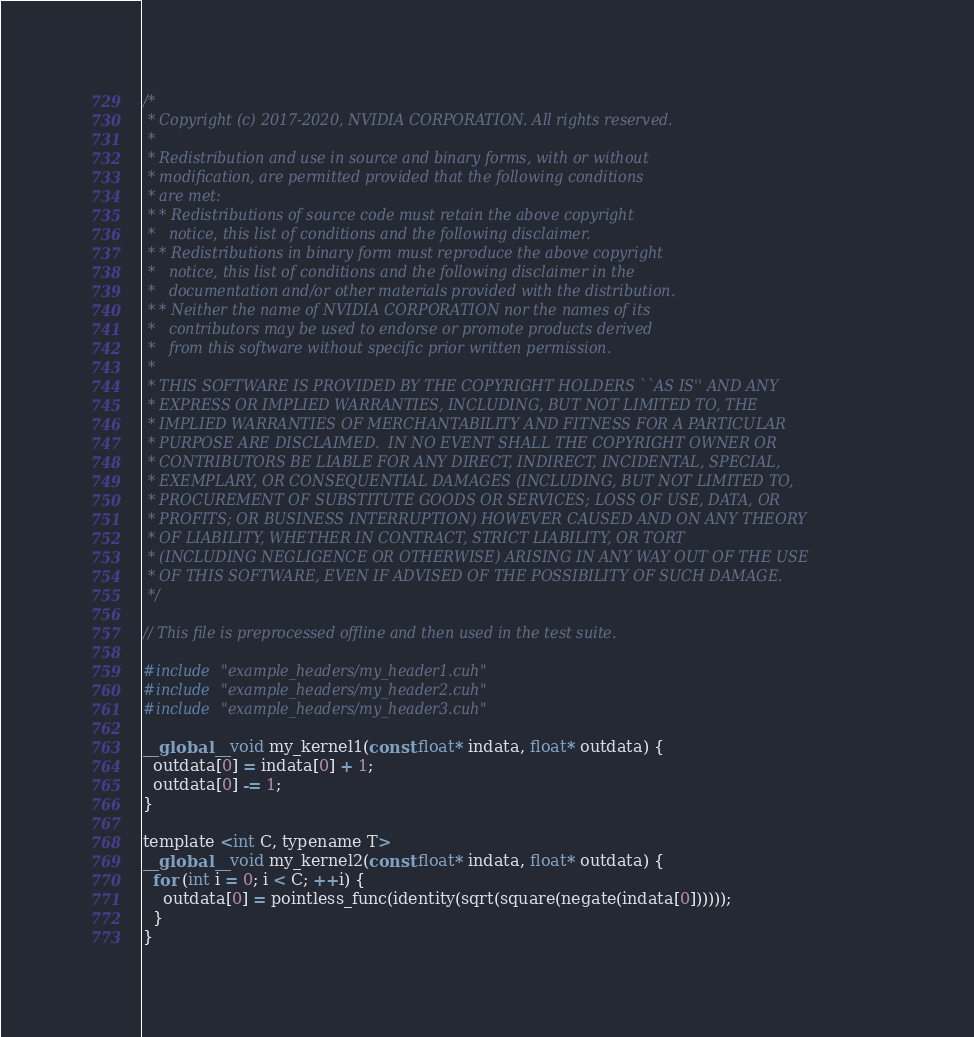<code> <loc_0><loc_0><loc_500><loc_500><_Cuda_>/*
 * Copyright (c) 2017-2020, NVIDIA CORPORATION. All rights reserved.
 *
 * Redistribution and use in source and binary forms, with or without
 * modification, are permitted provided that the following conditions
 * are met:
 * * Redistributions of source code must retain the above copyright
 *   notice, this list of conditions and the following disclaimer.
 * * Redistributions in binary form must reproduce the above copyright
 *   notice, this list of conditions and the following disclaimer in the
 *   documentation and/or other materials provided with the distribution.
 * * Neither the name of NVIDIA CORPORATION nor the names of its
 *   contributors may be used to endorse or promote products derived
 *   from this software without specific prior written permission.
 *
 * THIS SOFTWARE IS PROVIDED BY THE COPYRIGHT HOLDERS ``AS IS'' AND ANY
 * EXPRESS OR IMPLIED WARRANTIES, INCLUDING, BUT NOT LIMITED TO, THE
 * IMPLIED WARRANTIES OF MERCHANTABILITY AND FITNESS FOR A PARTICULAR
 * PURPOSE ARE DISCLAIMED.  IN NO EVENT SHALL THE COPYRIGHT OWNER OR
 * CONTRIBUTORS BE LIABLE FOR ANY DIRECT, INDIRECT, INCIDENTAL, SPECIAL,
 * EXEMPLARY, OR CONSEQUENTIAL DAMAGES (INCLUDING, BUT NOT LIMITED TO,
 * PROCUREMENT OF SUBSTITUTE GOODS OR SERVICES; LOSS OF USE, DATA, OR
 * PROFITS; OR BUSINESS INTERRUPTION) HOWEVER CAUSED AND ON ANY THEORY
 * OF LIABILITY, WHETHER IN CONTRACT, STRICT LIABILITY, OR TORT
 * (INCLUDING NEGLIGENCE OR OTHERWISE) ARISING IN ANY WAY OUT OF THE USE
 * OF THIS SOFTWARE, EVEN IF ADVISED OF THE POSSIBILITY OF SUCH DAMAGE.
 */

// This file is preprocessed offline and then used in the test suite.

#include "example_headers/my_header1.cuh"
#include "example_headers/my_header2.cuh"
#include "example_headers/my_header3.cuh"

__global__ void my_kernel1(const float* indata, float* outdata) {
  outdata[0] = indata[0] + 1;
  outdata[0] -= 1;
}

template <int C, typename T>
__global__ void my_kernel2(const float* indata, float* outdata) {
  for (int i = 0; i < C; ++i) {
    outdata[0] = pointless_func(identity(sqrt(square(negate(indata[0])))));
  }
}
</code> 